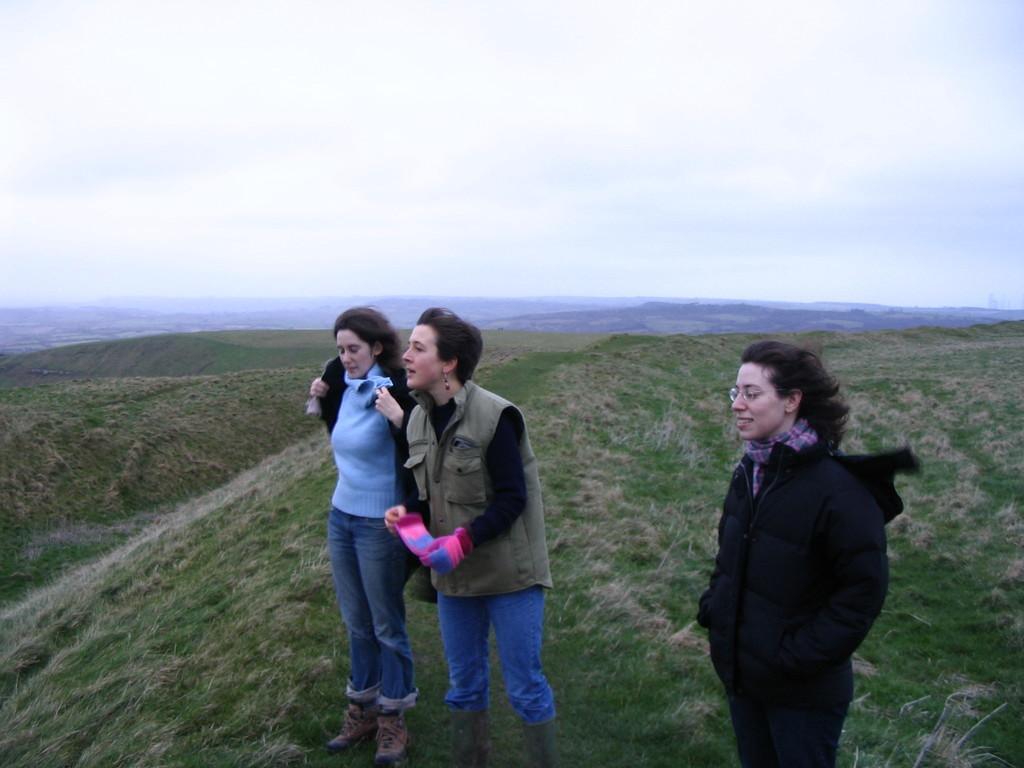Can you describe this image briefly? In this image I can see there are three women standing on the hill , at the top I can see the sky. 